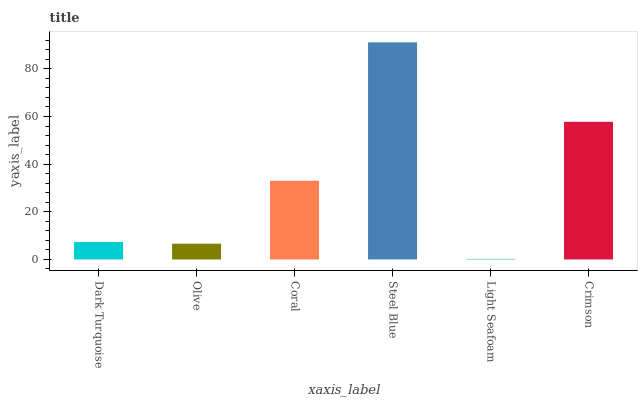Is Light Seafoam the minimum?
Answer yes or no. Yes. Is Steel Blue the maximum?
Answer yes or no. Yes. Is Olive the minimum?
Answer yes or no. No. Is Olive the maximum?
Answer yes or no. No. Is Dark Turquoise greater than Olive?
Answer yes or no. Yes. Is Olive less than Dark Turquoise?
Answer yes or no. Yes. Is Olive greater than Dark Turquoise?
Answer yes or no. No. Is Dark Turquoise less than Olive?
Answer yes or no. No. Is Coral the high median?
Answer yes or no. Yes. Is Dark Turquoise the low median?
Answer yes or no. Yes. Is Dark Turquoise the high median?
Answer yes or no. No. Is Coral the low median?
Answer yes or no. No. 